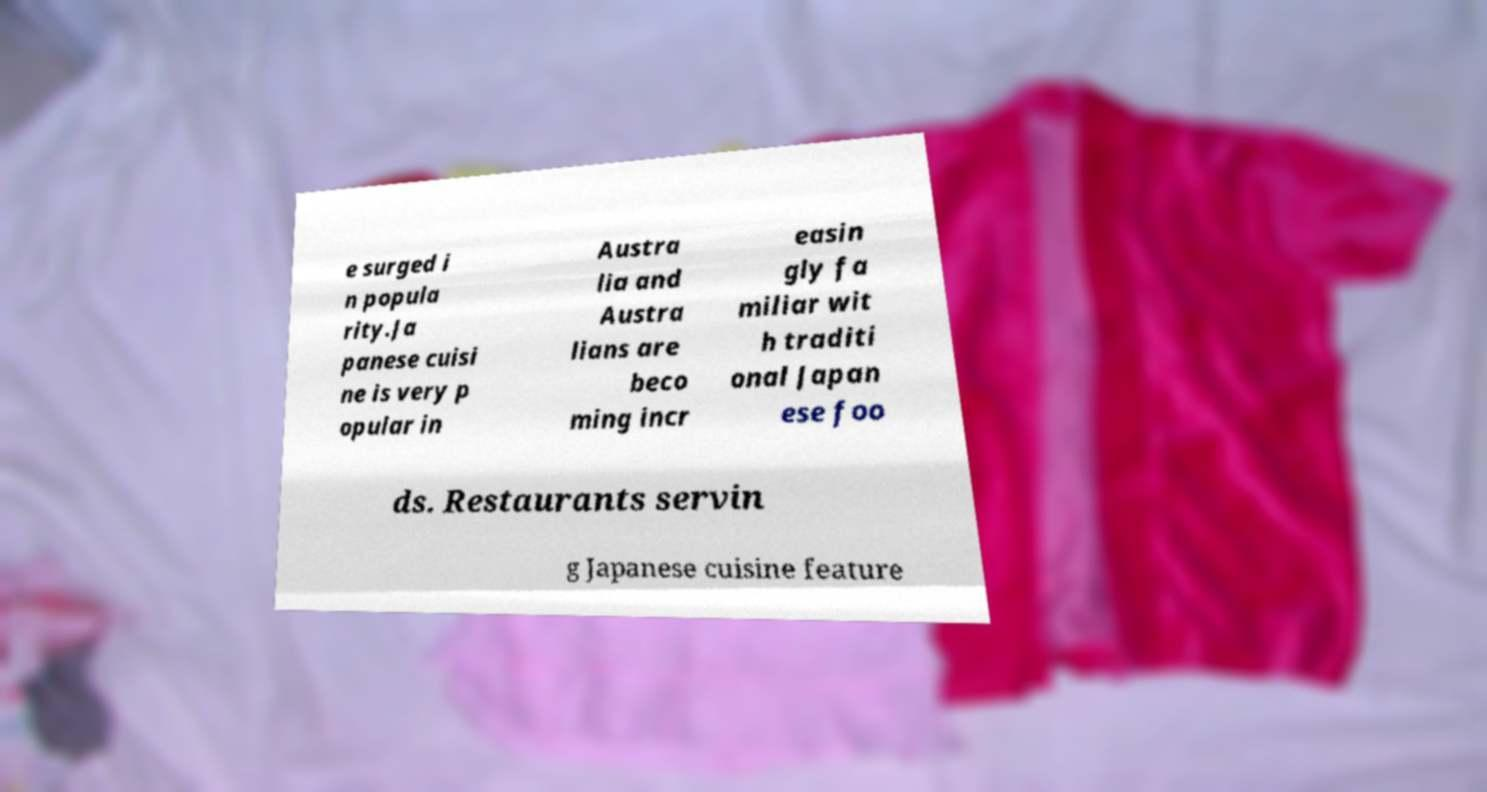There's text embedded in this image that I need extracted. Can you transcribe it verbatim? e surged i n popula rity.Ja panese cuisi ne is very p opular in Austra lia and Austra lians are beco ming incr easin gly fa miliar wit h traditi onal Japan ese foo ds. Restaurants servin g Japanese cuisine feature 